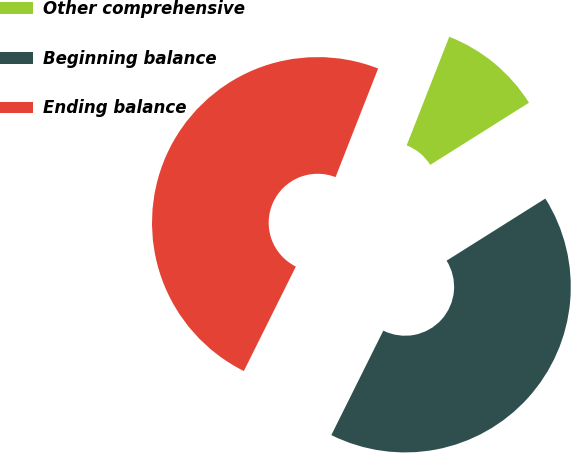<chart> <loc_0><loc_0><loc_500><loc_500><pie_chart><fcel>Other comprehensive<fcel>Beginning balance<fcel>Ending balance<nl><fcel>10.11%<fcel>41.29%<fcel>48.6%<nl></chart> 